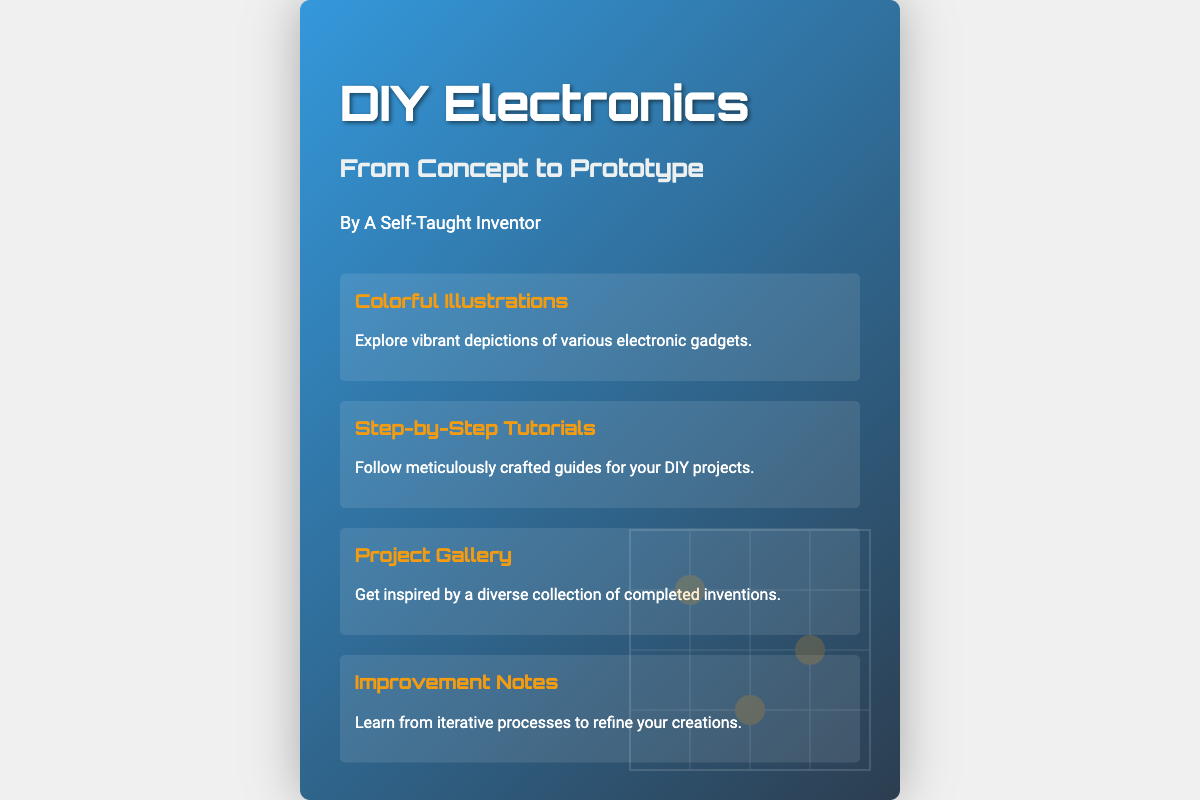What is the title of the book? The title of the book is prominently displayed at the top of the cover.
Answer: DIY Electronics Who is the author? The author’s name is listed under the title, indicating the creator of the book.
Answer: A Self-Taught Inventor What is the subtitle of the book? The subtitle provides additional context about the book’s content.
Answer: From Concept to Prototype How many sections are there in the content? The document lists four distinct sections providing detailed information.
Answer: Four What type of content does the book offer under 'Project Gallery'? This section promotes creativity and inspiration for readers by showcasing completed projects.
Answer: Completed inventions What color theme is used for the book cover? The book cover features a gradient background composed of two primary colors.
Answer: Blue and dark blue What is mentioned in the 'Improvement Notes' section? This section discusses a specific approach to enhancing projects through analysis.
Answer: Iterative processes What type of illustrations are included? This describes the visual aspect that adds engagement and interest for the readers.
Answer: Colorful illustrations What kind of tutorials can be found in the book? The type of guides detailed here helps readers execute their DIY projects effectively.
Answer: Step-by-Step Tutorials 